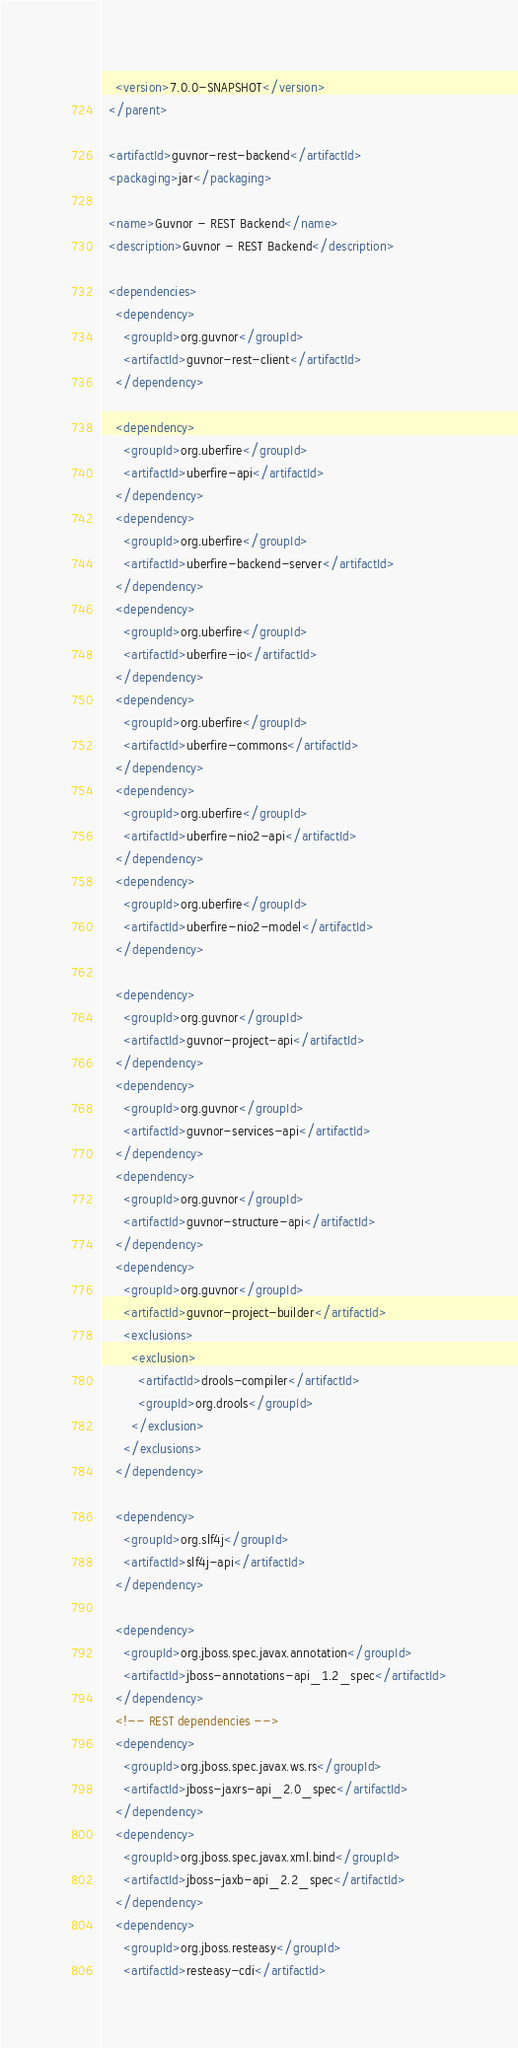<code> <loc_0><loc_0><loc_500><loc_500><_XML_>    <version>7.0.0-SNAPSHOT</version>
  </parent>

  <artifactId>guvnor-rest-backend</artifactId>
  <packaging>jar</packaging>

  <name>Guvnor - REST Backend</name>
  <description>Guvnor - REST Backend</description>

  <dependencies>
    <dependency>
      <groupId>org.guvnor</groupId>
      <artifactId>guvnor-rest-client</artifactId>
    </dependency>

    <dependency>
      <groupId>org.uberfire</groupId>
      <artifactId>uberfire-api</artifactId>
    </dependency>
    <dependency>
      <groupId>org.uberfire</groupId>
      <artifactId>uberfire-backend-server</artifactId>
    </dependency>
    <dependency>
      <groupId>org.uberfire</groupId>
      <artifactId>uberfire-io</artifactId>
    </dependency>
    <dependency>
      <groupId>org.uberfire</groupId>
      <artifactId>uberfire-commons</artifactId>
    </dependency>
    <dependency>
      <groupId>org.uberfire</groupId>
      <artifactId>uberfire-nio2-api</artifactId>
    </dependency>
    <dependency>
      <groupId>org.uberfire</groupId>
      <artifactId>uberfire-nio2-model</artifactId>
    </dependency>

    <dependency>
      <groupId>org.guvnor</groupId>
      <artifactId>guvnor-project-api</artifactId>
    </dependency>
    <dependency>
      <groupId>org.guvnor</groupId>
      <artifactId>guvnor-services-api</artifactId>
    </dependency>
    <dependency>
      <groupId>org.guvnor</groupId>
      <artifactId>guvnor-structure-api</artifactId>
    </dependency>
    <dependency>
      <groupId>org.guvnor</groupId>
      <artifactId>guvnor-project-builder</artifactId>
      <exclusions>
        <exclusion>
          <artifactId>drools-compiler</artifactId>
          <groupId>org.drools</groupId>
        </exclusion>
      </exclusions>
    </dependency>

    <dependency>
      <groupId>org.slf4j</groupId>
      <artifactId>slf4j-api</artifactId>
    </dependency>

    <dependency>
      <groupId>org.jboss.spec.javax.annotation</groupId>
      <artifactId>jboss-annotations-api_1.2_spec</artifactId>
    </dependency>
    <!-- REST dependencies -->
    <dependency>
      <groupId>org.jboss.spec.javax.ws.rs</groupId>
      <artifactId>jboss-jaxrs-api_2.0_spec</artifactId>
    </dependency>
    <dependency>
      <groupId>org.jboss.spec.javax.xml.bind</groupId>
      <artifactId>jboss-jaxb-api_2.2_spec</artifactId>
    </dependency>
    <dependency>
      <groupId>org.jboss.resteasy</groupId>
      <artifactId>resteasy-cdi</artifactId></code> 